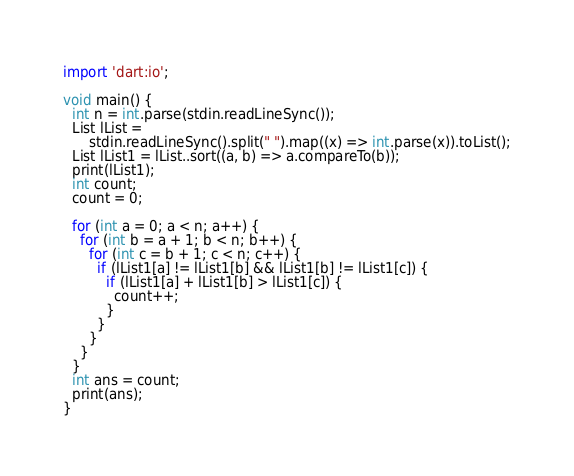<code> <loc_0><loc_0><loc_500><loc_500><_Dart_>import 'dart:io';

void main() {
  int n = int.parse(stdin.readLineSync());
  List lList =
      stdin.readLineSync().split(" ").map((x) => int.parse(x)).toList();
  List lList1 = lList..sort((a, b) => a.compareTo(b));
  print(lList1);
  int count;
  count = 0;

  for (int a = 0; a < n; a++) {
    for (int b = a + 1; b < n; b++) {
      for (int c = b + 1; c < n; c++) {
        if (lList1[a] != lList1[b] && lList1[b] != lList1[c]) {
          if (lList1[a] + lList1[b] > lList1[c]) {
            count++;
          }
        }
      }
    }
  }
  int ans = count;
  print(ans);
}
</code> 